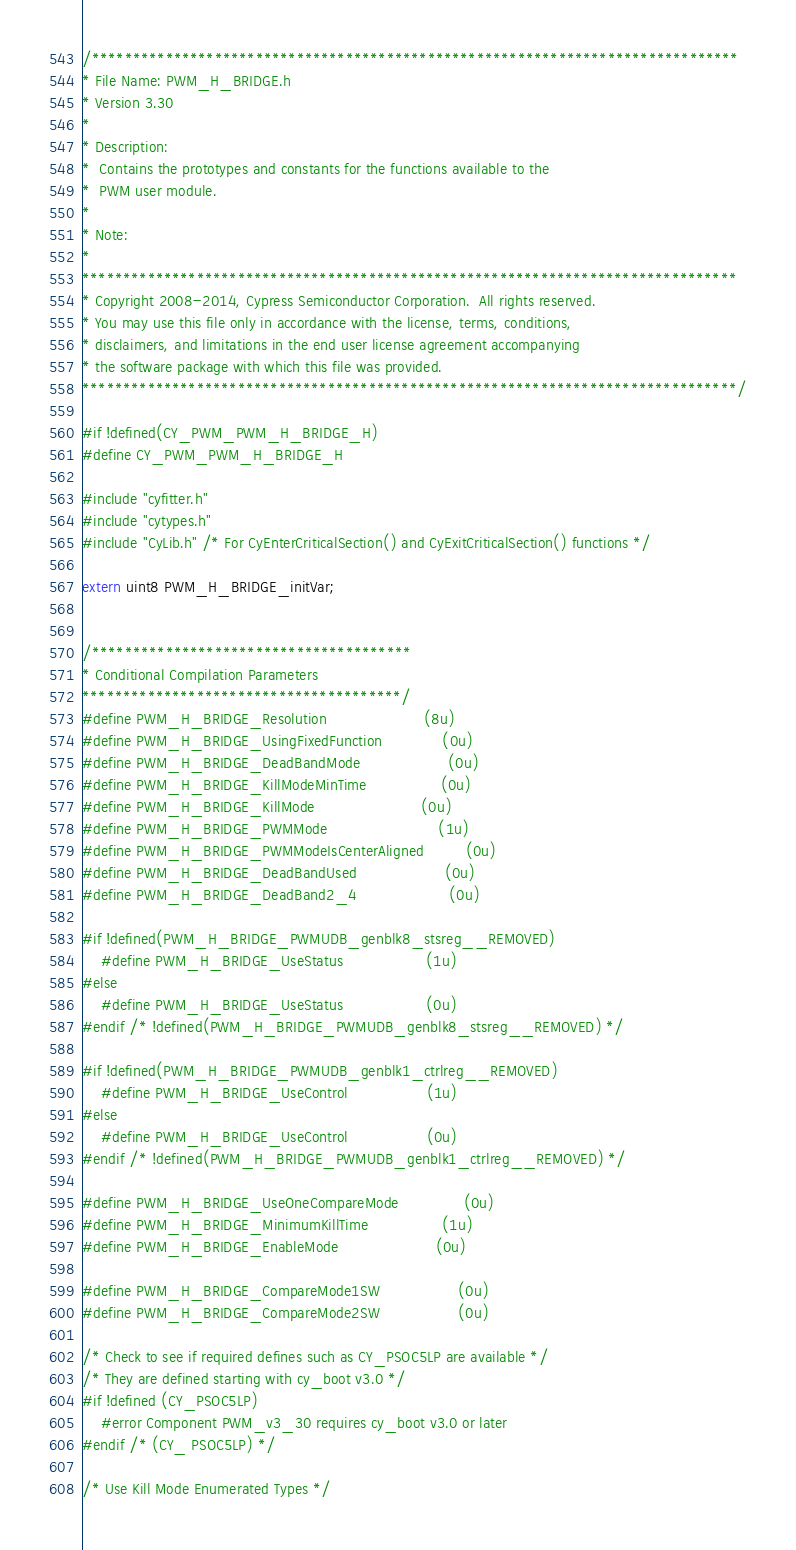Convert code to text. <code><loc_0><loc_0><loc_500><loc_500><_C_>/*******************************************************************************
* File Name: PWM_H_BRIDGE.h
* Version 3.30
*
* Description:
*  Contains the prototypes and constants for the functions available to the
*  PWM user module.
*
* Note:
*
********************************************************************************
* Copyright 2008-2014, Cypress Semiconductor Corporation.  All rights reserved.
* You may use this file only in accordance with the license, terms, conditions,
* disclaimers, and limitations in the end user license agreement accompanying
* the software package with which this file was provided.
********************************************************************************/

#if !defined(CY_PWM_PWM_H_BRIDGE_H)
#define CY_PWM_PWM_H_BRIDGE_H

#include "cyfitter.h"
#include "cytypes.h"
#include "CyLib.h" /* For CyEnterCriticalSection() and CyExitCriticalSection() functions */

extern uint8 PWM_H_BRIDGE_initVar;


/***************************************
* Conditional Compilation Parameters
***************************************/
#define PWM_H_BRIDGE_Resolution                     (8u)
#define PWM_H_BRIDGE_UsingFixedFunction             (0u)
#define PWM_H_BRIDGE_DeadBandMode                   (0u)
#define PWM_H_BRIDGE_KillModeMinTime                (0u)
#define PWM_H_BRIDGE_KillMode                       (0u)
#define PWM_H_BRIDGE_PWMMode                        (1u)
#define PWM_H_BRIDGE_PWMModeIsCenterAligned         (0u)
#define PWM_H_BRIDGE_DeadBandUsed                   (0u)
#define PWM_H_BRIDGE_DeadBand2_4                    (0u)

#if !defined(PWM_H_BRIDGE_PWMUDB_genblk8_stsreg__REMOVED)
    #define PWM_H_BRIDGE_UseStatus                  (1u)
#else
    #define PWM_H_BRIDGE_UseStatus                  (0u)
#endif /* !defined(PWM_H_BRIDGE_PWMUDB_genblk8_stsreg__REMOVED) */

#if !defined(PWM_H_BRIDGE_PWMUDB_genblk1_ctrlreg__REMOVED)
    #define PWM_H_BRIDGE_UseControl                 (1u)
#else
    #define PWM_H_BRIDGE_UseControl                 (0u)
#endif /* !defined(PWM_H_BRIDGE_PWMUDB_genblk1_ctrlreg__REMOVED) */

#define PWM_H_BRIDGE_UseOneCompareMode              (0u)
#define PWM_H_BRIDGE_MinimumKillTime                (1u)
#define PWM_H_BRIDGE_EnableMode                     (0u)

#define PWM_H_BRIDGE_CompareMode1SW                 (0u)
#define PWM_H_BRIDGE_CompareMode2SW                 (0u)

/* Check to see if required defines such as CY_PSOC5LP are available */
/* They are defined starting with cy_boot v3.0 */
#if !defined (CY_PSOC5LP)
    #error Component PWM_v3_30 requires cy_boot v3.0 or later
#endif /* (CY_ PSOC5LP) */

/* Use Kill Mode Enumerated Types */</code> 